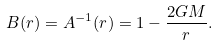Convert formula to latex. <formula><loc_0><loc_0><loc_500><loc_500>B ( r ) = A ^ { - 1 } ( r ) = 1 - \frac { 2 G M } { r } .</formula> 